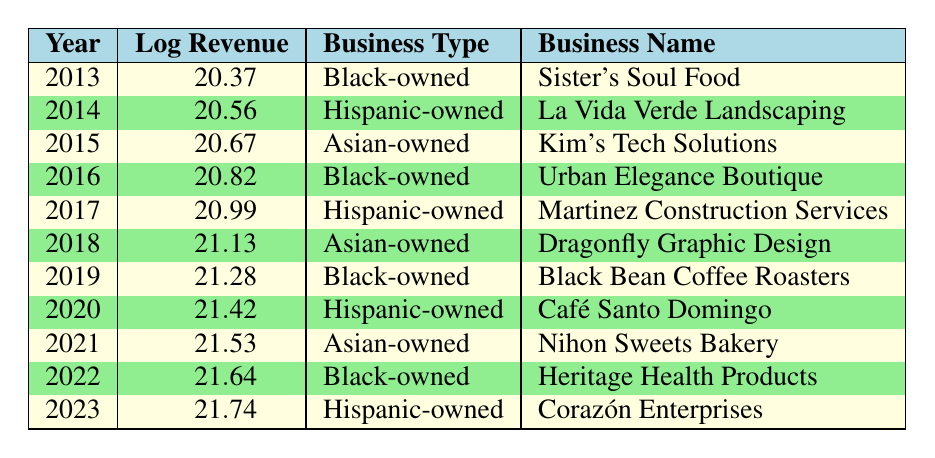What was the log revenue for the year 2019? The log revenue for 2019 is listed directly in the table under "Log Revenue." Upon checking that row, it shows 21.28.
Answer: 21.28 Which business had the highest log revenue in 2023? By examining the last row of the table, 2023 corresponds to "Corazón Enterprises," which has a log revenue of 21.74, the highest value in the table.
Answer: 21.74 How much did Hispanic-owned businesses generate in log revenue between 2014 and 2023? The log revenues for Hispanic-owned businesses in that range are 20.56 (2014), 20.99 (2017), 21.42 (2020), and 21.74 (2023). Adding these log revenues gives 20.56 + 20.99 + 21.42 + 21.74 = 84.71.
Answer: 84.71 Is the business "Sister's Soul Food" the only Black-owned business listed in 2013? The table confirms there is only one entry for the year 2013, which is "Sister's Soul Food," indicating there are no other Black-owned businesses listed for that year.
Answer: Yes Which business type had the highest log revenue in 2022 and how much was it? In the year 2022, "Heritage Health Products" is listed as Black-owned with a log revenue of 21.64. It is the only entry for that year, thus it is the highest for 2022.
Answer: 21.64 How many years show a consistent increase in log revenue? By examining the log revenues year by year, they are all progressively increasing from 2013 (20.37) to 2023 (21.74), demonstrating a consistent increase across all 11 annual data points.
Answer: 11 years What is the difference in log revenue between the highest and lowest years? The highest log revenue in 2023 is 21.74 and the lowest in 2013 is 20.37. Calculating the difference gives 21.74 - 20.37 = 1.37, showing the change in log revenue over the decade.
Answer: 1.37 Did Asian-owned businesses generate lower log revenue than Black-owned businesses in 2015? In 2015, the log revenue for Asian-owned businesses (20.67) is less than that of Black-owned businesses (20.82 in 2016). However, for 2015, the only comparison is with 2015 itself, and since 20.67 is less than any Black-owned business's revenue from previous years, the answer is yes to this specific year.
Answer: Yes 